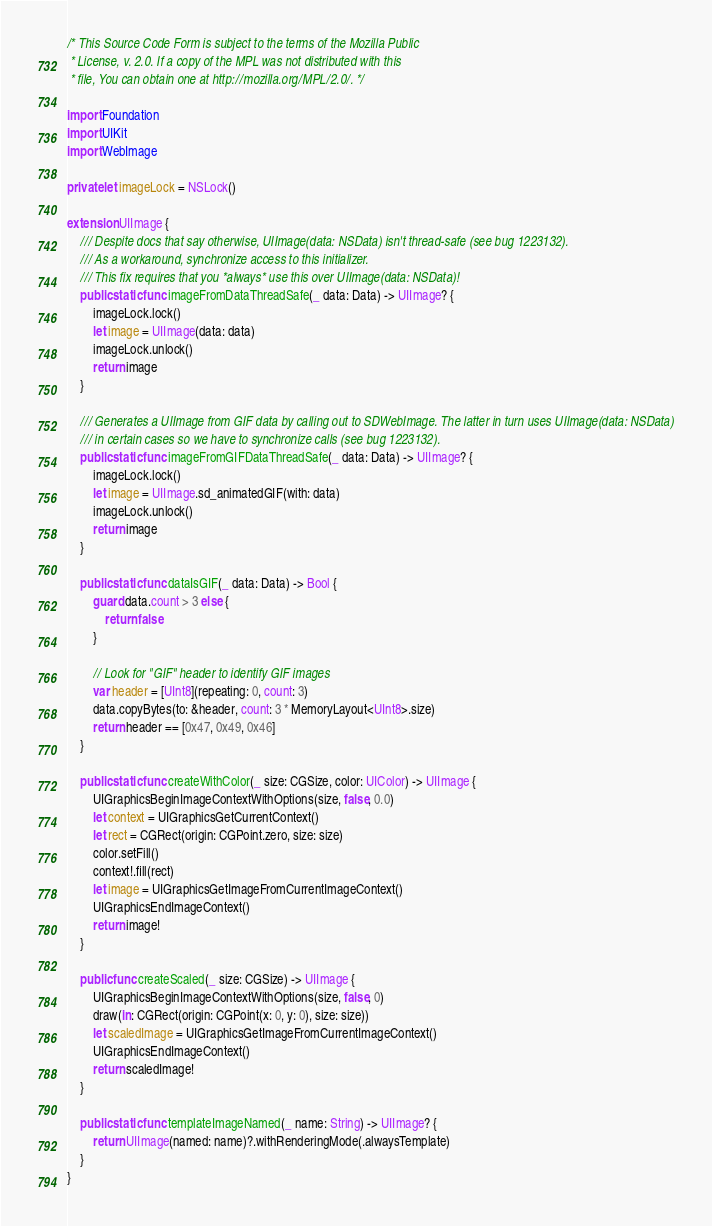<code> <loc_0><loc_0><loc_500><loc_500><_Swift_>/* This Source Code Form is subject to the terms of the Mozilla Public
 * License, v. 2.0. If a copy of the MPL was not distributed with this
 * file, You can obtain one at http://mozilla.org/MPL/2.0/. */

import Foundation
import UIKit
import WebImage

private let imageLock = NSLock()

extension UIImage {
    /// Despite docs that say otherwise, UIImage(data: NSData) isn't thread-safe (see bug 1223132).
    /// As a workaround, synchronize access to this initializer.
    /// This fix requires that you *always* use this over UIImage(data: NSData)!
    public static func imageFromDataThreadSafe(_ data: Data) -> UIImage? {
        imageLock.lock()
        let image = UIImage(data: data)
        imageLock.unlock()
        return image
    }

    /// Generates a UIImage from GIF data by calling out to SDWebImage. The latter in turn uses UIImage(data: NSData)
    /// in certain cases so we have to synchronize calls (see bug 1223132).
    public static func imageFromGIFDataThreadSafe(_ data: Data) -> UIImage? {
        imageLock.lock()
        let image = UIImage.sd_animatedGIF(with: data)
        imageLock.unlock()
        return image
    }

    public static func dataIsGIF(_ data: Data) -> Bool {
        guard data.count > 3 else {
            return false
        }

        // Look for "GIF" header to identify GIF images
        var header = [UInt8](repeating: 0, count: 3)
        data.copyBytes(to: &header, count: 3 * MemoryLayout<UInt8>.size)
        return header == [0x47, 0x49, 0x46]
    }

    public static func createWithColor(_ size: CGSize, color: UIColor) -> UIImage {
        UIGraphicsBeginImageContextWithOptions(size, false, 0.0)
        let context = UIGraphicsGetCurrentContext()
        let rect = CGRect(origin: CGPoint.zero, size: size)
        color.setFill()
        context!.fill(rect)
        let image = UIGraphicsGetImageFromCurrentImageContext()
        UIGraphicsEndImageContext()
        return image!
    }

    public func createScaled(_ size: CGSize) -> UIImage {
        UIGraphicsBeginImageContextWithOptions(size, false, 0)
        draw(in: CGRect(origin: CGPoint(x: 0, y: 0), size: size))
        let scaledImage = UIGraphicsGetImageFromCurrentImageContext()
        UIGraphicsEndImageContext()
        return scaledImage!
    }

    public static func templateImageNamed(_ name: String) -> UIImage? {
        return UIImage(named: name)?.withRenderingMode(.alwaysTemplate)
    }
}
</code> 